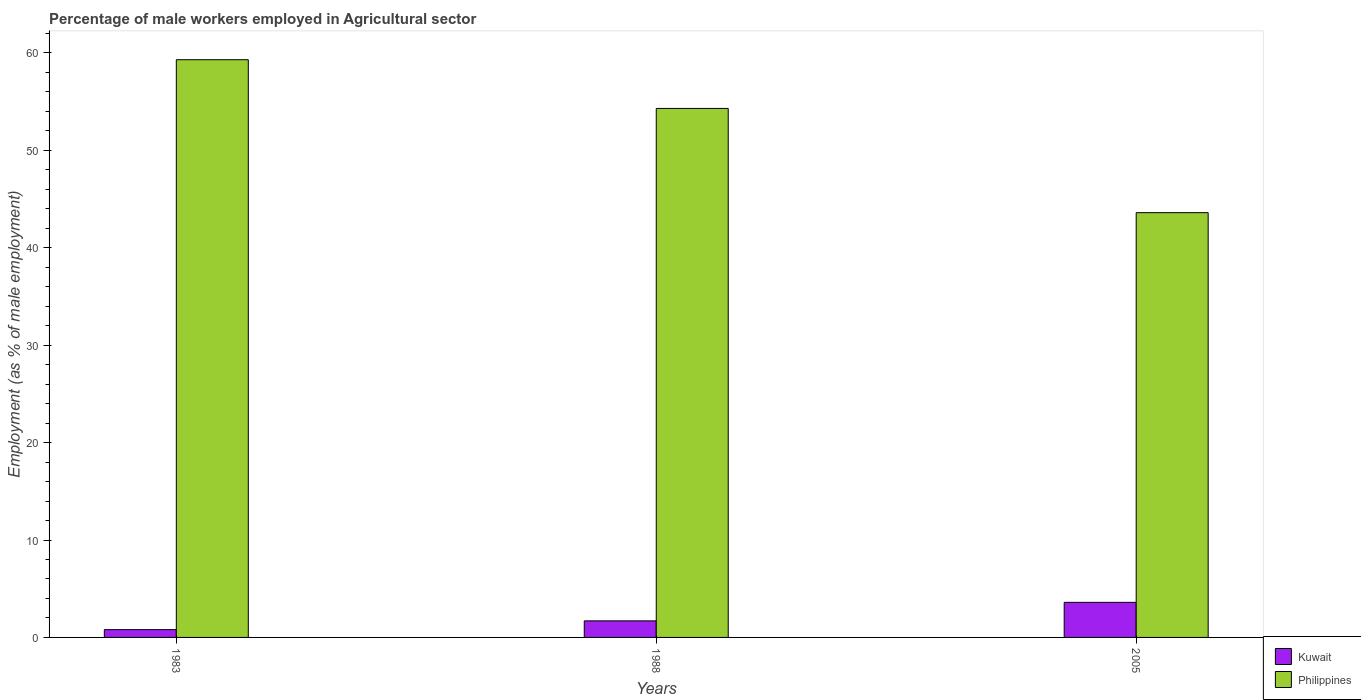How many bars are there on the 2nd tick from the right?
Your answer should be compact. 2. What is the label of the 3rd group of bars from the left?
Give a very brief answer. 2005. In how many cases, is the number of bars for a given year not equal to the number of legend labels?
Give a very brief answer. 0. What is the percentage of male workers employed in Agricultural sector in Philippines in 1988?
Keep it short and to the point. 54.3. Across all years, what is the maximum percentage of male workers employed in Agricultural sector in Kuwait?
Provide a short and direct response. 3.6. Across all years, what is the minimum percentage of male workers employed in Agricultural sector in Kuwait?
Offer a terse response. 0.8. In which year was the percentage of male workers employed in Agricultural sector in Kuwait minimum?
Ensure brevity in your answer.  1983. What is the total percentage of male workers employed in Agricultural sector in Kuwait in the graph?
Provide a short and direct response. 6.1. What is the difference between the percentage of male workers employed in Agricultural sector in Philippines in 1988 and the percentage of male workers employed in Agricultural sector in Kuwait in 1983?
Provide a succinct answer. 53.5. What is the average percentage of male workers employed in Agricultural sector in Kuwait per year?
Keep it short and to the point. 2.03. In the year 1988, what is the difference between the percentage of male workers employed in Agricultural sector in Philippines and percentage of male workers employed in Agricultural sector in Kuwait?
Provide a short and direct response. 52.6. What is the ratio of the percentage of male workers employed in Agricultural sector in Philippines in 1983 to that in 1988?
Make the answer very short. 1.09. Is the difference between the percentage of male workers employed in Agricultural sector in Philippines in 1983 and 2005 greater than the difference between the percentage of male workers employed in Agricultural sector in Kuwait in 1983 and 2005?
Provide a short and direct response. Yes. What is the difference between the highest and the second highest percentage of male workers employed in Agricultural sector in Kuwait?
Provide a short and direct response. 1.9. What is the difference between the highest and the lowest percentage of male workers employed in Agricultural sector in Philippines?
Offer a very short reply. 15.7. In how many years, is the percentage of male workers employed in Agricultural sector in Kuwait greater than the average percentage of male workers employed in Agricultural sector in Kuwait taken over all years?
Provide a short and direct response. 1. What does the 1st bar from the left in 1983 represents?
Your response must be concise. Kuwait. Are all the bars in the graph horizontal?
Your answer should be very brief. No. How many years are there in the graph?
Make the answer very short. 3. Are the values on the major ticks of Y-axis written in scientific E-notation?
Provide a succinct answer. No. Does the graph contain any zero values?
Offer a very short reply. No. How are the legend labels stacked?
Your response must be concise. Vertical. What is the title of the graph?
Ensure brevity in your answer.  Percentage of male workers employed in Agricultural sector. Does "Virgin Islands" appear as one of the legend labels in the graph?
Keep it short and to the point. No. What is the label or title of the X-axis?
Your answer should be compact. Years. What is the label or title of the Y-axis?
Make the answer very short. Employment (as % of male employment). What is the Employment (as % of male employment) of Kuwait in 1983?
Your answer should be compact. 0.8. What is the Employment (as % of male employment) in Philippines in 1983?
Make the answer very short. 59.3. What is the Employment (as % of male employment) in Kuwait in 1988?
Your response must be concise. 1.7. What is the Employment (as % of male employment) in Philippines in 1988?
Give a very brief answer. 54.3. What is the Employment (as % of male employment) in Kuwait in 2005?
Make the answer very short. 3.6. What is the Employment (as % of male employment) of Philippines in 2005?
Offer a very short reply. 43.6. Across all years, what is the maximum Employment (as % of male employment) in Kuwait?
Make the answer very short. 3.6. Across all years, what is the maximum Employment (as % of male employment) in Philippines?
Provide a succinct answer. 59.3. Across all years, what is the minimum Employment (as % of male employment) in Kuwait?
Your response must be concise. 0.8. Across all years, what is the minimum Employment (as % of male employment) in Philippines?
Your answer should be compact. 43.6. What is the total Employment (as % of male employment) of Philippines in the graph?
Offer a very short reply. 157.2. What is the difference between the Employment (as % of male employment) in Kuwait in 1983 and that in 1988?
Make the answer very short. -0.9. What is the difference between the Employment (as % of male employment) of Philippines in 1983 and that in 1988?
Your answer should be very brief. 5. What is the difference between the Employment (as % of male employment) of Kuwait in 1983 and that in 2005?
Keep it short and to the point. -2.8. What is the difference between the Employment (as % of male employment) of Kuwait in 1988 and that in 2005?
Provide a short and direct response. -1.9. What is the difference between the Employment (as % of male employment) in Kuwait in 1983 and the Employment (as % of male employment) in Philippines in 1988?
Give a very brief answer. -53.5. What is the difference between the Employment (as % of male employment) of Kuwait in 1983 and the Employment (as % of male employment) of Philippines in 2005?
Offer a very short reply. -42.8. What is the difference between the Employment (as % of male employment) of Kuwait in 1988 and the Employment (as % of male employment) of Philippines in 2005?
Provide a succinct answer. -41.9. What is the average Employment (as % of male employment) in Kuwait per year?
Ensure brevity in your answer.  2.03. What is the average Employment (as % of male employment) of Philippines per year?
Your answer should be compact. 52.4. In the year 1983, what is the difference between the Employment (as % of male employment) of Kuwait and Employment (as % of male employment) of Philippines?
Offer a terse response. -58.5. In the year 1988, what is the difference between the Employment (as % of male employment) of Kuwait and Employment (as % of male employment) of Philippines?
Make the answer very short. -52.6. What is the ratio of the Employment (as % of male employment) in Kuwait in 1983 to that in 1988?
Provide a succinct answer. 0.47. What is the ratio of the Employment (as % of male employment) in Philippines in 1983 to that in 1988?
Provide a succinct answer. 1.09. What is the ratio of the Employment (as % of male employment) of Kuwait in 1983 to that in 2005?
Your answer should be very brief. 0.22. What is the ratio of the Employment (as % of male employment) of Philippines in 1983 to that in 2005?
Your response must be concise. 1.36. What is the ratio of the Employment (as % of male employment) in Kuwait in 1988 to that in 2005?
Your answer should be compact. 0.47. What is the ratio of the Employment (as % of male employment) in Philippines in 1988 to that in 2005?
Your answer should be compact. 1.25. What is the difference between the highest and the second highest Employment (as % of male employment) of Philippines?
Ensure brevity in your answer.  5. 